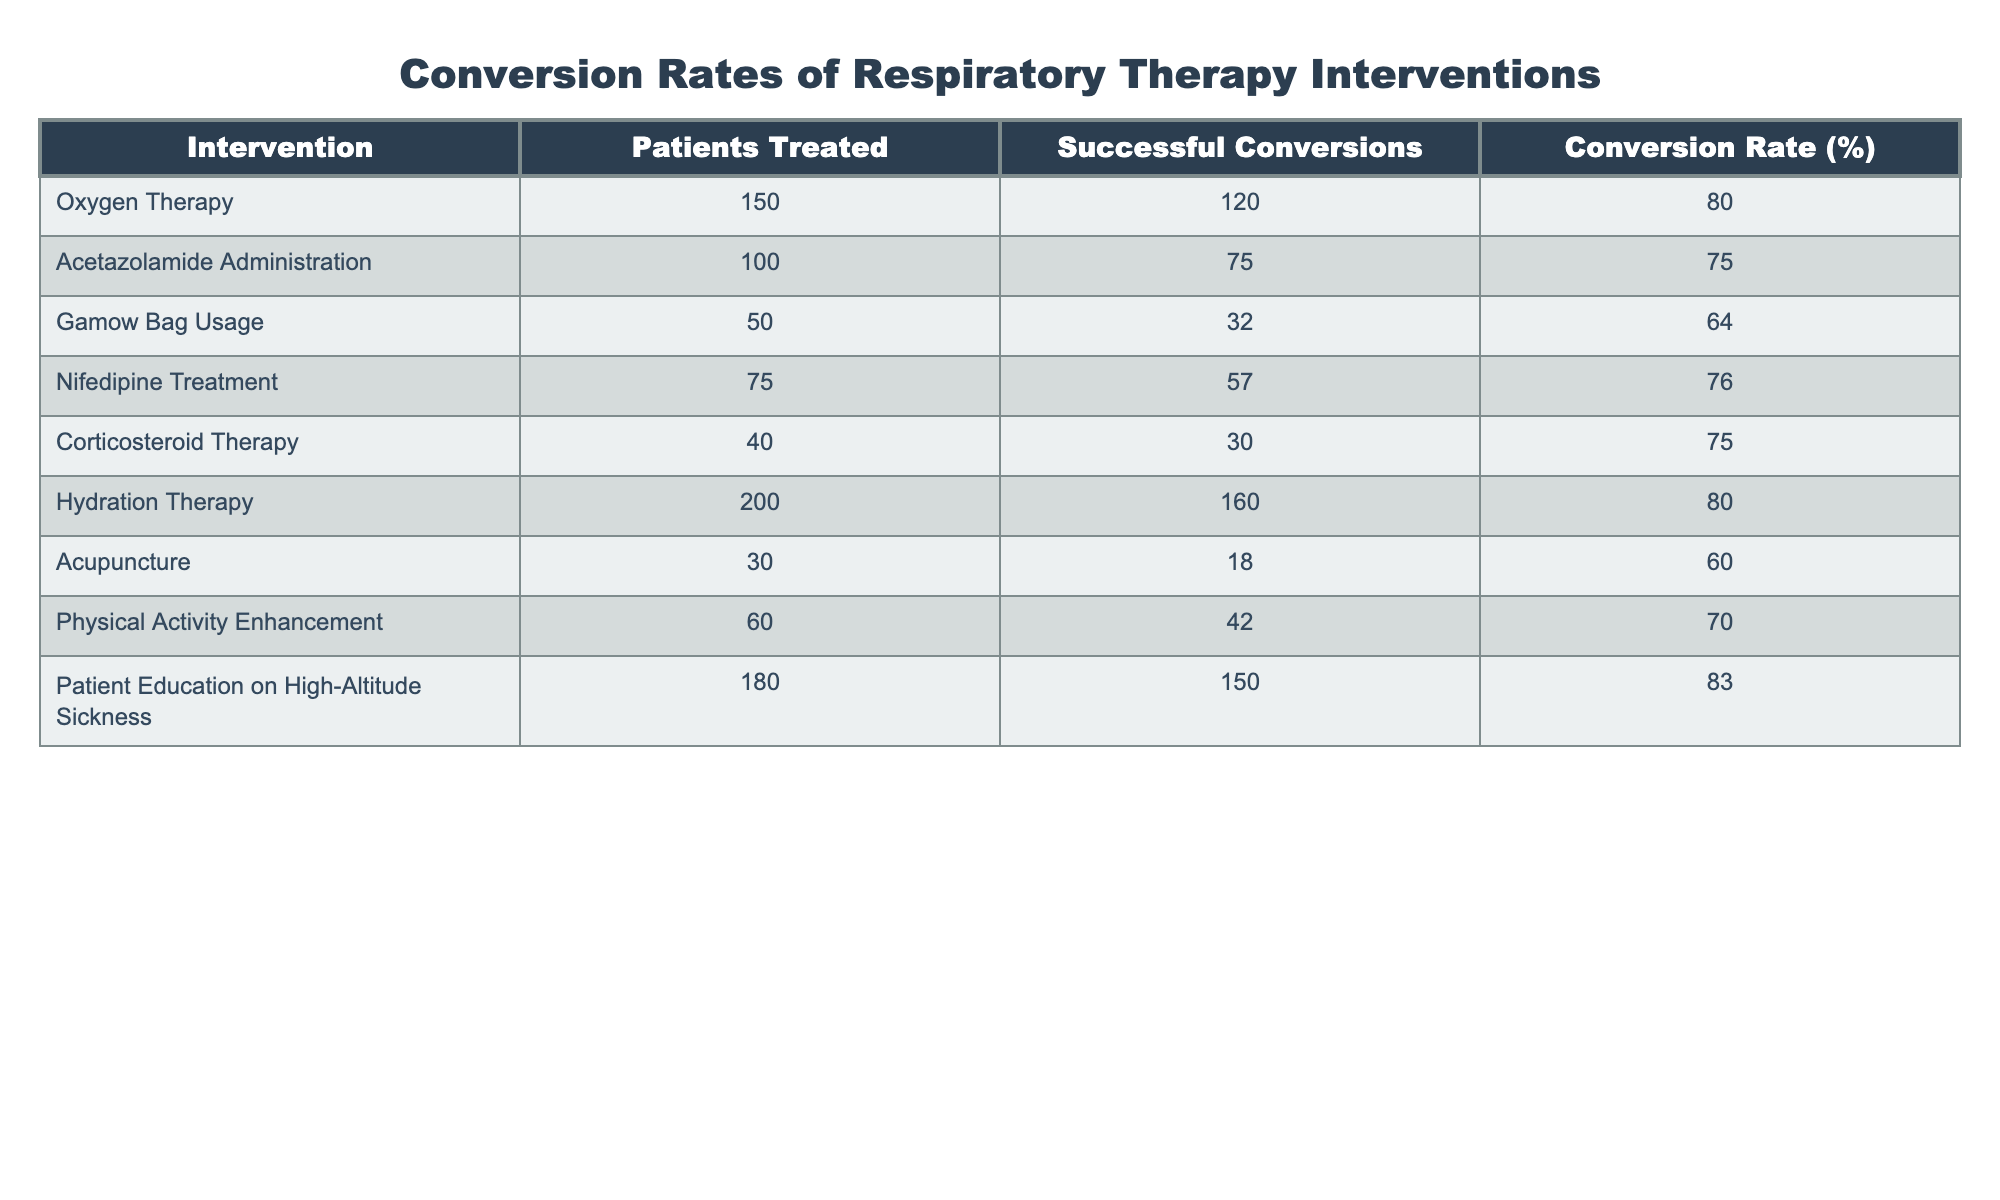What is the conversion rate for Oxygen Therapy? The conversion rate for Oxygen Therapy is directly listed in the table under the "Conversion Rate (%)" column for the respective intervention. It shows a value of 80%.
Answer: 80% How many patients were treated with Hydration Therapy? The number of patients treated with Hydration Therapy can be found in the "Patients Treated" column specifically for that intervention. It lists 200 patients.
Answer: 200 What is the total number of successful conversions for all interventions? To find the total successful conversions, sum up the "Successful Conversions" column: 120 + 75 + 32 + 57 + 30 + 160 + 18 + 42 + 150 = 564.
Answer: 564 Is the conversion rate for Acupuncture higher than that for Nifedipine Treatment? Looking at the conversion rates for both interventions: Acupuncture has a conversion rate of 60% and Nifedipine Treatment has a conversion rate of 76%. Since 60% is less than 76%, the statement is false.
Answer: No What is the average conversion rate of all interventions listed? The average conversion rate is calculated by summing all the conversion rates and dividing by the number of interventions. The conversion rates are: 80, 75, 64, 76, 75, 80, 60, 70, 83. Summing these gives  80 + 75 + 64 + 76 + 75 + 80 + 60 + 70 + 83 =  672. There are 9 interventions, hence the average is 672 / 9 = 74.67.
Answer: 74.67 Which intervention has the highest conversion rate? By comparing the "Conversion Rate (%)" values across all interventions, the maximum value is 83% associated with "Patient Education on High-Altitude Sickness".
Answer: 83% What is the difference in the number of patients treated between Gamow Bag Usage and Acetazolamide Administration? To find the difference in patients treated, subtract the number of patients treated with Acetazolamide Administration (100) from Gamow Bag Usage (50): 50 - 100 = -50. The absolute value is 50. Therefore, Gamow Bag Usage has 50 fewer patients treated.
Answer: 50 Do more than 50% of the patients who received Physical Activity Enhancement have successful conversions? Check the values in the "Successful Conversions" and "Patients Treated" columns for Physical Activity Enhancement. There are 42 successful conversions out of 60 patients treated. The ratio is 42 / 60 = 0.7 which is 70%, which is more than 50%. Therefore, the statement is true.
Answer: Yes What percentage of the total patients treated underwent Acetazolamide Administration? The total number of patients treated across all interventions is the sum of the "Patients Treated" column: 150 + 100 + 50 + 75 + 40 + 200 + 30 + 60 + 180 = 885. For Acetazolamide Administration, 100 patients were treated, hence the percentage is (100 / 885) * 100 = 11.29%.
Answer: 11.29% 